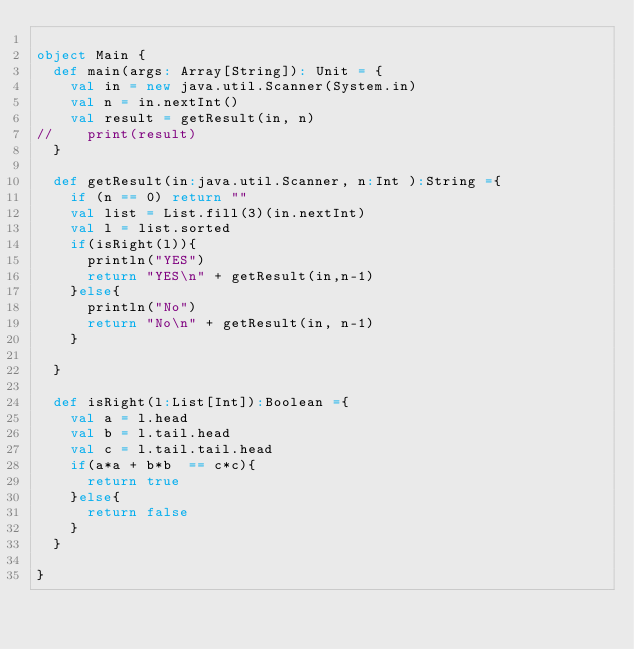<code> <loc_0><loc_0><loc_500><loc_500><_Scala_>
object Main {
  def main(args: Array[String]): Unit = {
    val in = new java.util.Scanner(System.in)
    val n = in.nextInt()
    val result = getResult(in, n)
//    print(result)
  }
  
  def getResult(in:java.util.Scanner, n:Int ):String ={
    if (n == 0) return ""
    val list = List.fill(3)(in.nextInt)
    val l = list.sorted
    if(isRight(l)){
      println("YES")
      return "YES\n" + getResult(in,n-1)
    }else{
      println("No")
      return "No\n" + getResult(in, n-1)
    }
    
  }
  
  def isRight(l:List[Int]):Boolean ={
    val a = l.head
    val b = l.tail.head
    val c = l.tail.tail.head
    if(a*a + b*b  == c*c){
      return true
    }else{
      return false
    }
  }
  
}</code> 